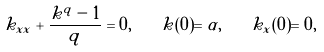Convert formula to latex. <formula><loc_0><loc_0><loc_500><loc_500>k _ { x x } + \frac { k ^ { q } - 1 } { q } = 0 , \quad k ( 0 ) = \alpha , \quad k _ { x } ( 0 ) = 0 ,</formula> 